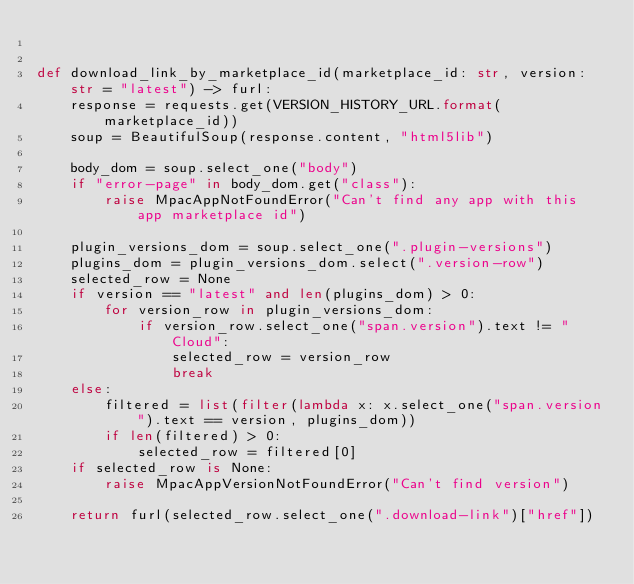<code> <loc_0><loc_0><loc_500><loc_500><_Python_>

def download_link_by_marketplace_id(marketplace_id: str, version: str = "latest") -> furl:
    response = requests.get(VERSION_HISTORY_URL.format(marketplace_id))
    soup = BeautifulSoup(response.content, "html5lib")

    body_dom = soup.select_one("body")
    if "error-page" in body_dom.get("class"):
        raise MpacAppNotFoundError("Can't find any app with this app marketplace id")

    plugin_versions_dom = soup.select_one(".plugin-versions")
    plugins_dom = plugin_versions_dom.select(".version-row")
    selected_row = None
    if version == "latest" and len(plugins_dom) > 0:
        for version_row in plugin_versions_dom:
            if version_row.select_one("span.version").text != "Cloud":
                selected_row = version_row
                break
    else:
        filtered = list(filter(lambda x: x.select_one("span.version").text == version, plugins_dom))
        if len(filtered) > 0:
            selected_row = filtered[0]
    if selected_row is None:
        raise MpacAppVersionNotFoundError("Can't find version")

    return furl(selected_row.select_one(".download-link")["href"])
</code> 